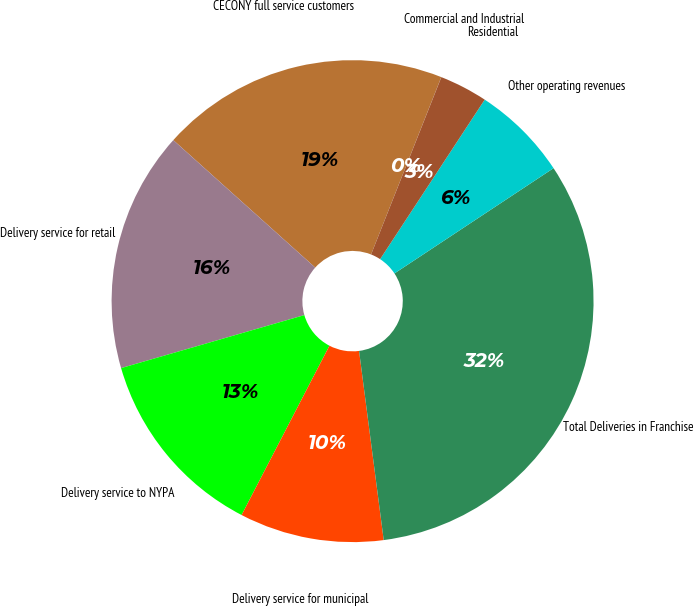<chart> <loc_0><loc_0><loc_500><loc_500><pie_chart><fcel>CECONY full service customers<fcel>Delivery service for retail<fcel>Delivery service to NYPA<fcel>Delivery service for municipal<fcel>Total Deliveries in Franchise<fcel>Other operating revenues<fcel>Residential<fcel>Commercial and Industrial<nl><fcel>19.35%<fcel>16.13%<fcel>12.9%<fcel>9.68%<fcel>32.24%<fcel>6.46%<fcel>3.23%<fcel>0.01%<nl></chart> 